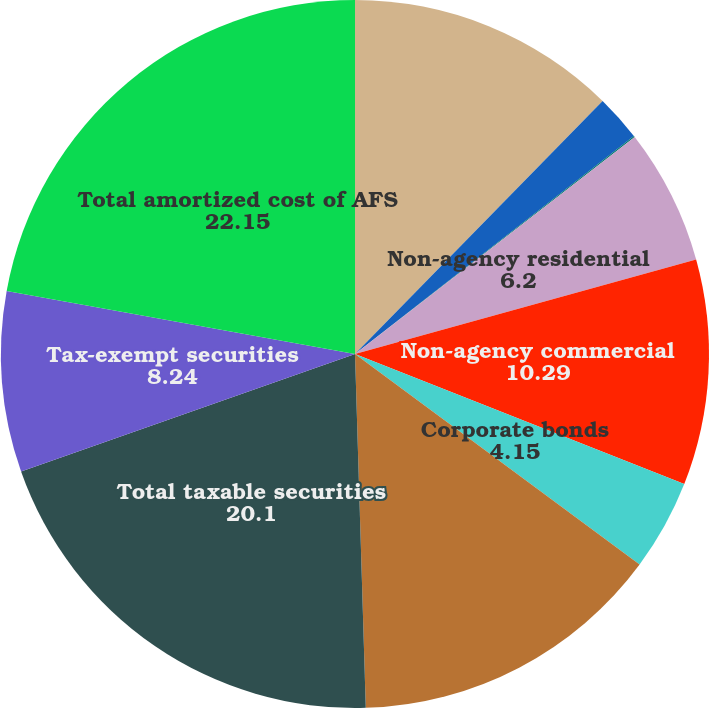Convert chart. <chart><loc_0><loc_0><loc_500><loc_500><pie_chart><fcel>US Treasury and agency<fcel>Agency<fcel>Agency-collateralized mortgage<fcel>Non-agency residential<fcel>Non-agency commercial<fcel>Corporate bonds<fcel>Other taxable securities<fcel>Total taxable securities<fcel>Tax-exempt securities<fcel>Total amortized cost of AFS<nl><fcel>12.33%<fcel>2.11%<fcel>0.06%<fcel>6.2%<fcel>10.29%<fcel>4.15%<fcel>14.38%<fcel>20.1%<fcel>8.24%<fcel>22.15%<nl></chart> 